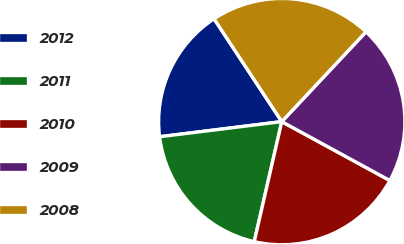Convert chart to OTSL. <chart><loc_0><loc_0><loc_500><loc_500><pie_chart><fcel>2012<fcel>2011<fcel>2010<fcel>2009<fcel>2008<nl><fcel>17.69%<fcel>19.45%<fcel>20.65%<fcel>20.95%<fcel>21.26%<nl></chart> 